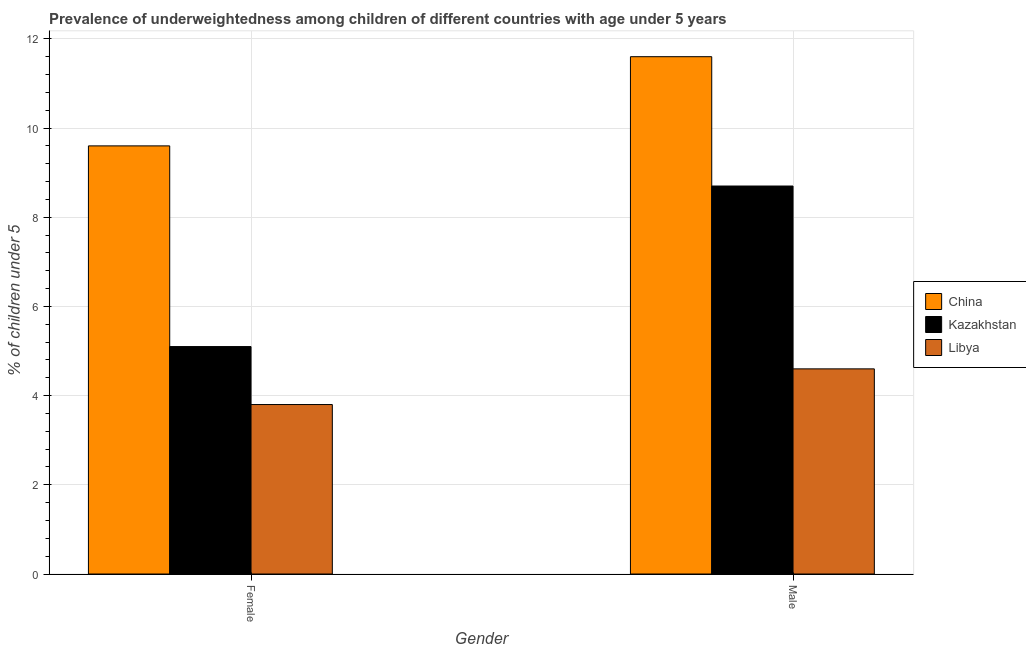How many different coloured bars are there?
Provide a short and direct response. 3. Are the number of bars on each tick of the X-axis equal?
Make the answer very short. Yes. What is the percentage of underweighted male children in China?
Provide a succinct answer. 11.6. Across all countries, what is the maximum percentage of underweighted male children?
Give a very brief answer. 11.6. Across all countries, what is the minimum percentage of underweighted male children?
Your answer should be very brief. 4.6. In which country was the percentage of underweighted male children maximum?
Provide a succinct answer. China. In which country was the percentage of underweighted male children minimum?
Your response must be concise. Libya. What is the total percentage of underweighted female children in the graph?
Offer a terse response. 18.5. What is the difference between the percentage of underweighted male children in China and that in Kazakhstan?
Make the answer very short. 2.9. What is the difference between the percentage of underweighted female children in China and the percentage of underweighted male children in Kazakhstan?
Your answer should be compact. 0.9. What is the average percentage of underweighted female children per country?
Your answer should be very brief. 6.17. What is the difference between the percentage of underweighted male children and percentage of underweighted female children in Libya?
Your answer should be very brief. 0.8. In how many countries, is the percentage of underweighted male children greater than 5.6 %?
Make the answer very short. 2. What is the ratio of the percentage of underweighted male children in Kazakhstan to that in China?
Your answer should be compact. 0.75. Is the percentage of underweighted male children in China less than that in Libya?
Your answer should be compact. No. What does the 2nd bar from the right in Female represents?
Ensure brevity in your answer.  Kazakhstan. How many legend labels are there?
Make the answer very short. 3. How are the legend labels stacked?
Your response must be concise. Vertical. What is the title of the graph?
Your answer should be very brief. Prevalence of underweightedness among children of different countries with age under 5 years. Does "Liechtenstein" appear as one of the legend labels in the graph?
Your answer should be very brief. No. What is the label or title of the Y-axis?
Give a very brief answer.  % of children under 5. What is the  % of children under 5 in China in Female?
Ensure brevity in your answer.  9.6. What is the  % of children under 5 of Kazakhstan in Female?
Keep it short and to the point. 5.1. What is the  % of children under 5 of Libya in Female?
Provide a short and direct response. 3.8. What is the  % of children under 5 in China in Male?
Provide a succinct answer. 11.6. What is the  % of children under 5 in Kazakhstan in Male?
Offer a very short reply. 8.7. What is the  % of children under 5 of Libya in Male?
Provide a succinct answer. 4.6. Across all Gender, what is the maximum  % of children under 5 in China?
Give a very brief answer. 11.6. Across all Gender, what is the maximum  % of children under 5 of Kazakhstan?
Your answer should be compact. 8.7. Across all Gender, what is the maximum  % of children under 5 of Libya?
Your response must be concise. 4.6. Across all Gender, what is the minimum  % of children under 5 in China?
Your answer should be compact. 9.6. Across all Gender, what is the minimum  % of children under 5 in Kazakhstan?
Provide a short and direct response. 5.1. Across all Gender, what is the minimum  % of children under 5 in Libya?
Provide a succinct answer. 3.8. What is the total  % of children under 5 of China in the graph?
Provide a short and direct response. 21.2. What is the total  % of children under 5 in Kazakhstan in the graph?
Your response must be concise. 13.8. What is the total  % of children under 5 of Libya in the graph?
Your response must be concise. 8.4. What is the difference between the  % of children under 5 in Libya in Female and that in Male?
Provide a succinct answer. -0.8. What is the difference between the  % of children under 5 of Kazakhstan in Female and the  % of children under 5 of Libya in Male?
Your answer should be very brief. 0.5. What is the average  % of children under 5 in China per Gender?
Your answer should be very brief. 10.6. What is the average  % of children under 5 in Kazakhstan per Gender?
Your response must be concise. 6.9. What is the average  % of children under 5 of Libya per Gender?
Your response must be concise. 4.2. What is the difference between the  % of children under 5 of China and  % of children under 5 of Libya in Female?
Your answer should be very brief. 5.8. What is the difference between the  % of children under 5 in China and  % of children under 5 in Kazakhstan in Male?
Provide a short and direct response. 2.9. What is the difference between the  % of children under 5 in China and  % of children under 5 in Libya in Male?
Offer a very short reply. 7. What is the ratio of the  % of children under 5 of China in Female to that in Male?
Keep it short and to the point. 0.83. What is the ratio of the  % of children under 5 in Kazakhstan in Female to that in Male?
Provide a short and direct response. 0.59. What is the ratio of the  % of children under 5 of Libya in Female to that in Male?
Ensure brevity in your answer.  0.83. What is the difference between the highest and the second highest  % of children under 5 of China?
Ensure brevity in your answer.  2. What is the difference between the highest and the second highest  % of children under 5 in Kazakhstan?
Make the answer very short. 3.6. What is the difference between the highest and the second highest  % of children under 5 in Libya?
Your answer should be compact. 0.8. What is the difference between the highest and the lowest  % of children under 5 of Kazakhstan?
Offer a terse response. 3.6. What is the difference between the highest and the lowest  % of children under 5 of Libya?
Keep it short and to the point. 0.8. 